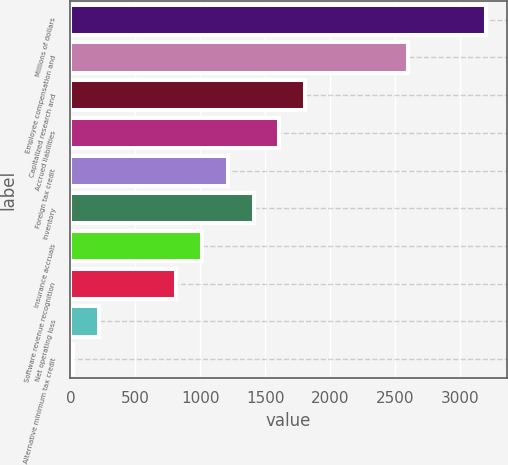Convert chart to OTSL. <chart><loc_0><loc_0><loc_500><loc_500><bar_chart><fcel>Millions of dollars<fcel>Employee compensation and<fcel>Capitalized research and<fcel>Accrued liabilities<fcel>Foreign tax credit<fcel>Inventory<fcel>Insurance accruals<fcel>Software revenue recognition<fcel>Net operating loss<fcel>Alternative minimum tax credit<nl><fcel>3199.8<fcel>2603.4<fcel>1808.2<fcel>1609.4<fcel>1211.8<fcel>1410.6<fcel>1013<fcel>814.2<fcel>217.8<fcel>19<nl></chart> 